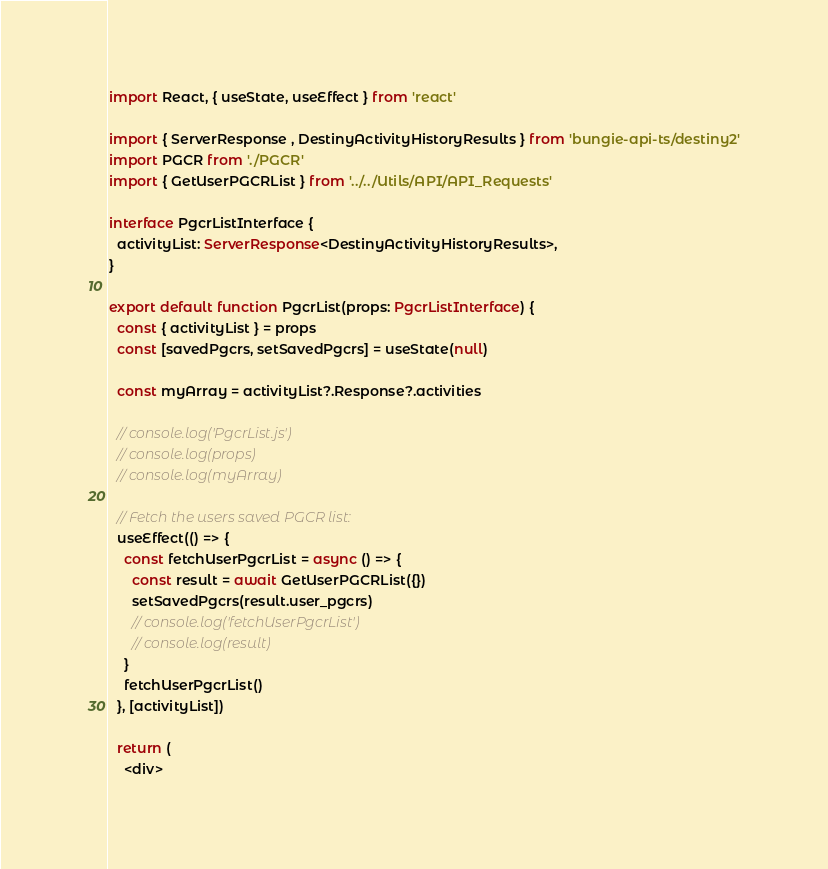<code> <loc_0><loc_0><loc_500><loc_500><_TypeScript_>import React, { useState, useEffect } from 'react'

import { ServerResponse , DestinyActivityHistoryResults } from 'bungie-api-ts/destiny2'
import PGCR from './PGCR'
import { GetUserPGCRList } from '../../Utils/API/API_Requests'

interface PgcrListInterface {
  activityList: ServerResponse<DestinyActivityHistoryResults>,
}

export default function PgcrList(props: PgcrListInterface) {
  const { activityList } = props
  const [savedPgcrs, setSavedPgcrs] = useState(null)

  const myArray = activityList?.Response?.activities

  // console.log('PgcrList.js')
  // console.log(props)
  // console.log(myArray)

  // Fetch the users saved PGCR list:
  useEffect(() => {
    const fetchUserPgcrList = async () => {
      const result = await GetUserPGCRList({})
      setSavedPgcrs(result.user_pgcrs)
      // console.log('fetchUserPgcrList')
      // console.log(result)
    }
    fetchUserPgcrList()
  }, [activityList])

  return (
    <div></code> 